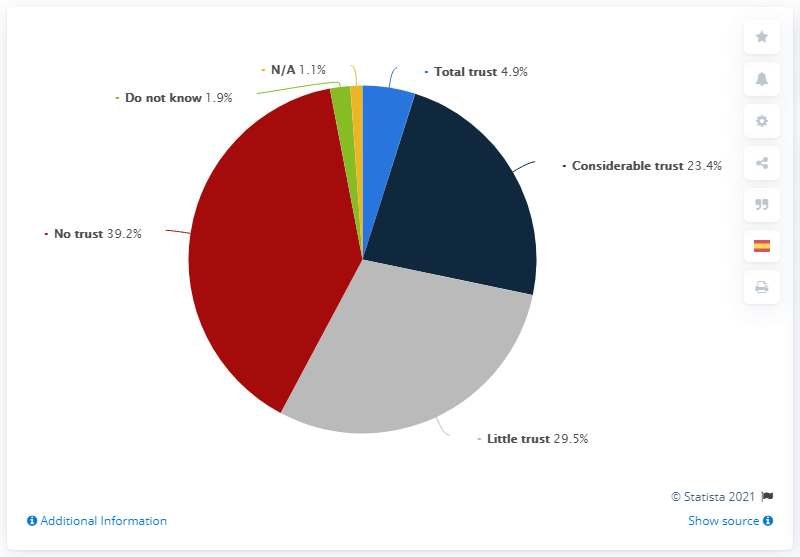What does this chart tell us about the level of trust? The chart illustrates varying levels of trust, with the largest segment being 'No trust' at 39.2%. It suggests a predominant skepticism or lack of confidence among the surveyed group, as 'Little trust' and 'No trust' together comprise over two-thirds of the responses. Could the 'Do not know' and 'N/A' responses impact the interpretation of this chart? Absolutely. The 'Do not know' at 1.9% and 'N/A' at 1.1% portions, though seemingly small, indicate a subset of respondents who either were unsure of their trust level or considered the question not applicable. Their inclusion reflects the reality that not every respondent has a clear stance on the subject, which adds nuance to the overall findings. 